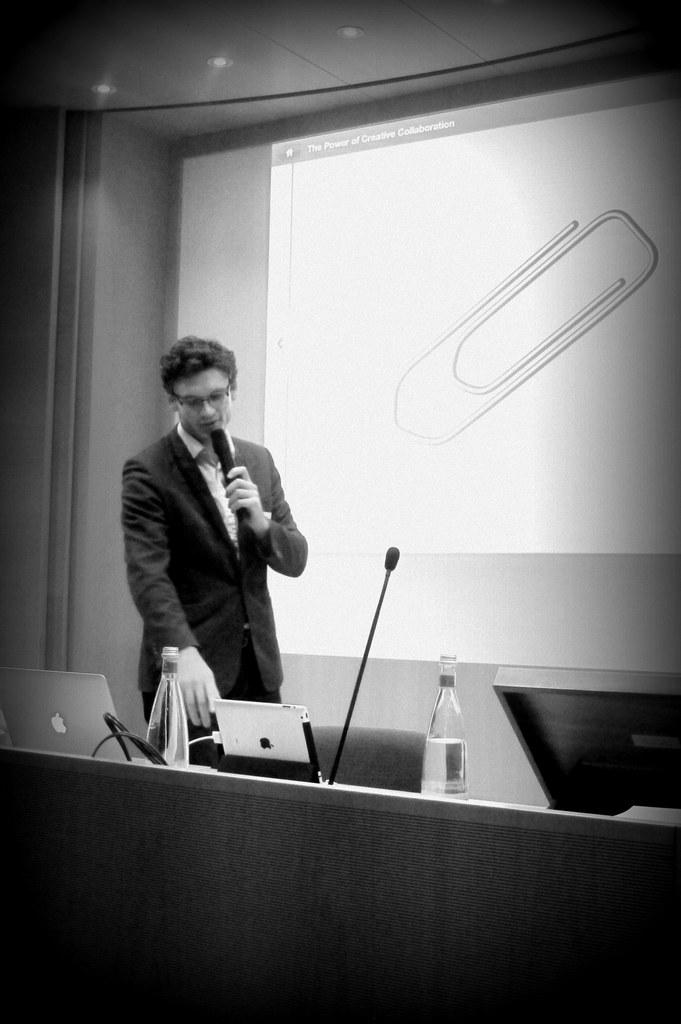What is the man in the image holding? The man is holding a mic. What objects are on the table in the image? There are laptops, a water bottle, and a mic on the table. What can be seen in the background of the image? There is a projector screen in the background of the image. What type of shoe is the man wearing in the image? The image does not show the man's shoes, so it is not possible to determine what type of shoe he is wearing. How does the man wash his hands in the image? There is no indication in the image that the man is washing his hands, so it cannot be determined from the picture. 